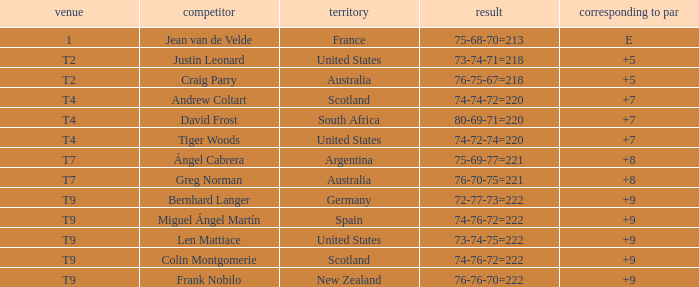For the match in which player David Frost scored a To Par of +7, what was the final score? 80-69-71=220. 